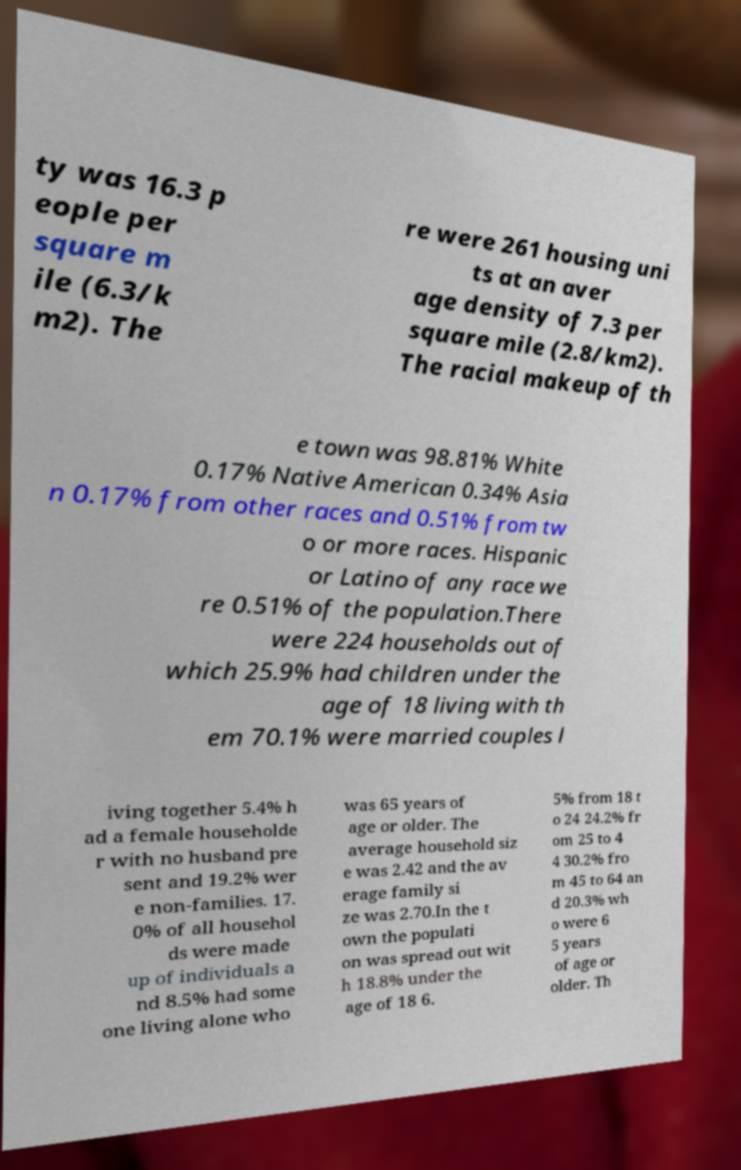What messages or text are displayed in this image? I need them in a readable, typed format. ty was 16.3 p eople per square m ile (6.3/k m2). The re were 261 housing uni ts at an aver age density of 7.3 per square mile (2.8/km2). The racial makeup of th e town was 98.81% White 0.17% Native American 0.34% Asia n 0.17% from other races and 0.51% from tw o or more races. Hispanic or Latino of any race we re 0.51% of the population.There were 224 households out of which 25.9% had children under the age of 18 living with th em 70.1% were married couples l iving together 5.4% h ad a female householde r with no husband pre sent and 19.2% wer e non-families. 17. 0% of all househol ds were made up of individuals a nd 8.5% had some one living alone who was 65 years of age or older. The average household siz e was 2.42 and the av erage family si ze was 2.70.In the t own the populati on was spread out wit h 18.8% under the age of 18 6. 5% from 18 t o 24 24.2% fr om 25 to 4 4 30.2% fro m 45 to 64 an d 20.3% wh o were 6 5 years of age or older. Th 